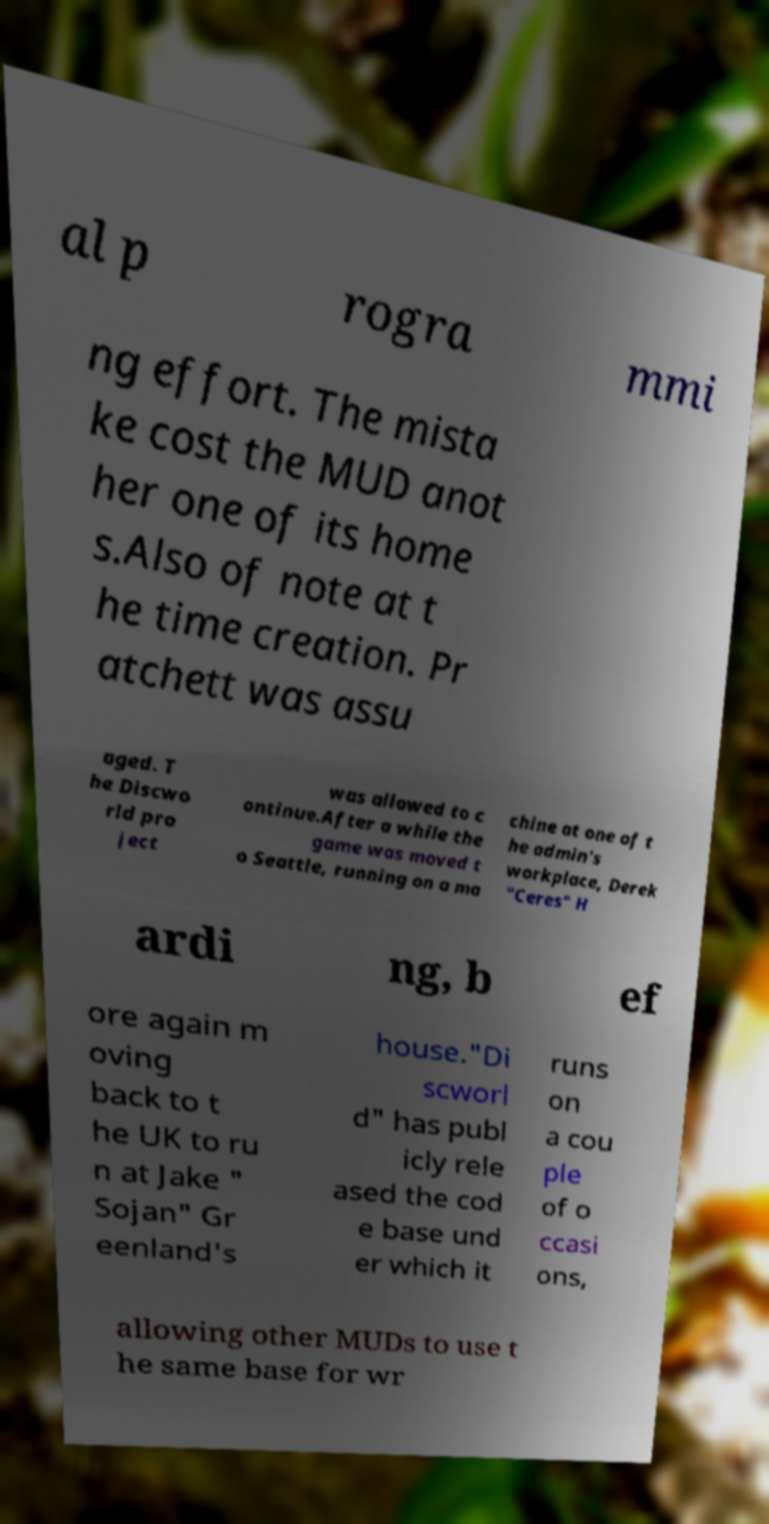There's text embedded in this image that I need extracted. Can you transcribe it verbatim? al p rogra mmi ng effort. The mista ke cost the MUD anot her one of its home s.Also of note at t he time creation. Pr atchett was assu aged. T he Discwo rld pro ject was allowed to c ontinue.After a while the game was moved t o Seattle, running on a ma chine at one of t he admin's workplace, Derek "Ceres" H ardi ng, b ef ore again m oving back to t he UK to ru n at Jake " Sojan" Gr eenland's house."Di scworl d" has publ icly rele ased the cod e base und er which it runs on a cou ple of o ccasi ons, allowing other MUDs to use t he same base for wr 